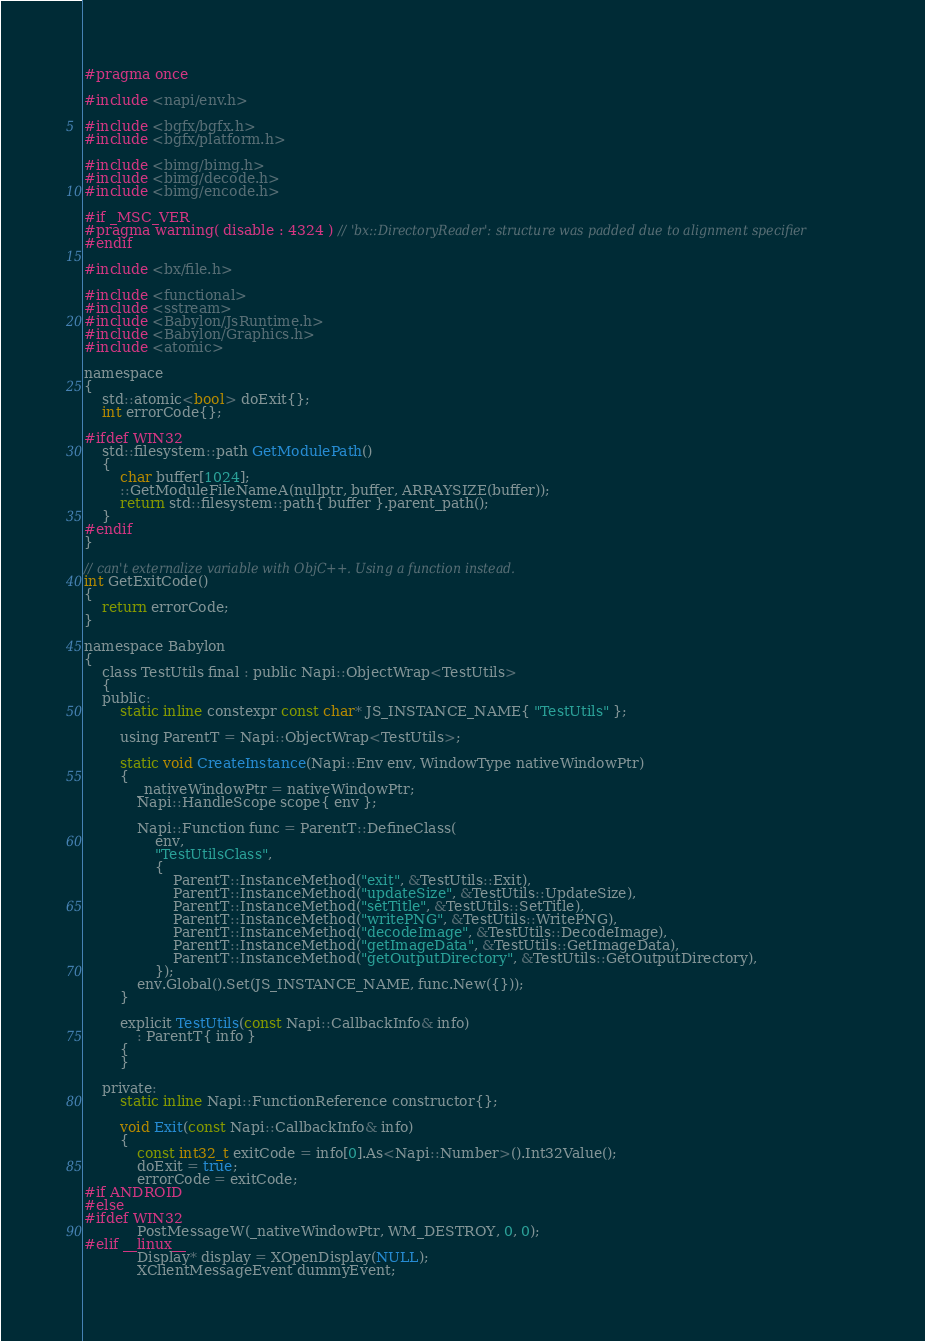Convert code to text. <code><loc_0><loc_0><loc_500><loc_500><_C_>#pragma once

#include <napi/env.h>

#include <bgfx/bgfx.h>
#include <bgfx/platform.h>

#include <bimg/bimg.h>
#include <bimg/decode.h>
#include <bimg/encode.h>

#if _MSC_VER
#pragma warning( disable : 4324 ) // 'bx::DirectoryReader': structure was padded due to alignment specifier
#endif

#include <bx/file.h>

#include <functional>
#include <sstream>
#include <Babylon/JsRuntime.h>
#include <Babylon/Graphics.h>
#include <atomic>

namespace
{
    std::atomic<bool> doExit{};
    int errorCode{};

#ifdef WIN32
    std::filesystem::path GetModulePath()
    {
        char buffer[1024];
        ::GetModuleFileNameA(nullptr, buffer, ARRAYSIZE(buffer));
        return std::filesystem::path{ buffer }.parent_path();
    }
#endif
}

// can't externalize variable with ObjC++. Using a function instead.
int GetExitCode()
{
    return errorCode;
}

namespace Babylon
{
    class TestUtils final : public Napi::ObjectWrap<TestUtils>
    {
    public:
        static inline constexpr const char* JS_INSTANCE_NAME{ "TestUtils" };

        using ParentT = Napi::ObjectWrap<TestUtils>;

        static void CreateInstance(Napi::Env env, WindowType nativeWindowPtr)
        {
            _nativeWindowPtr = nativeWindowPtr;
            Napi::HandleScope scope{ env };

            Napi::Function func = ParentT::DefineClass(
                env,
                "TestUtilsClass",
                {
                    ParentT::InstanceMethod("exit", &TestUtils::Exit),
                    ParentT::InstanceMethod("updateSize", &TestUtils::UpdateSize),
                    ParentT::InstanceMethod("setTitle", &TestUtils::SetTitle),
                    ParentT::InstanceMethod("writePNG", &TestUtils::WritePNG),
                    ParentT::InstanceMethod("decodeImage", &TestUtils::DecodeImage),
                    ParentT::InstanceMethod("getImageData", &TestUtils::GetImageData),
                    ParentT::InstanceMethod("getOutputDirectory", &TestUtils::GetOutputDirectory),
                });
            env.Global().Set(JS_INSTANCE_NAME, func.New({}));
        }

        explicit TestUtils(const Napi::CallbackInfo& info)
            : ParentT{ info }
        {
        }

    private:
        static inline Napi::FunctionReference constructor{};

        void Exit(const Napi::CallbackInfo& info)
        {
            const int32_t exitCode = info[0].As<Napi::Number>().Int32Value();
            doExit = true;
            errorCode = exitCode;
#if ANDROID
#else
#ifdef WIN32
            PostMessageW(_nativeWindowPtr, WM_DESTROY, 0, 0);
#elif __linux__
            Display* display = XOpenDisplay(NULL);
            XClientMessageEvent dummyEvent;</code> 